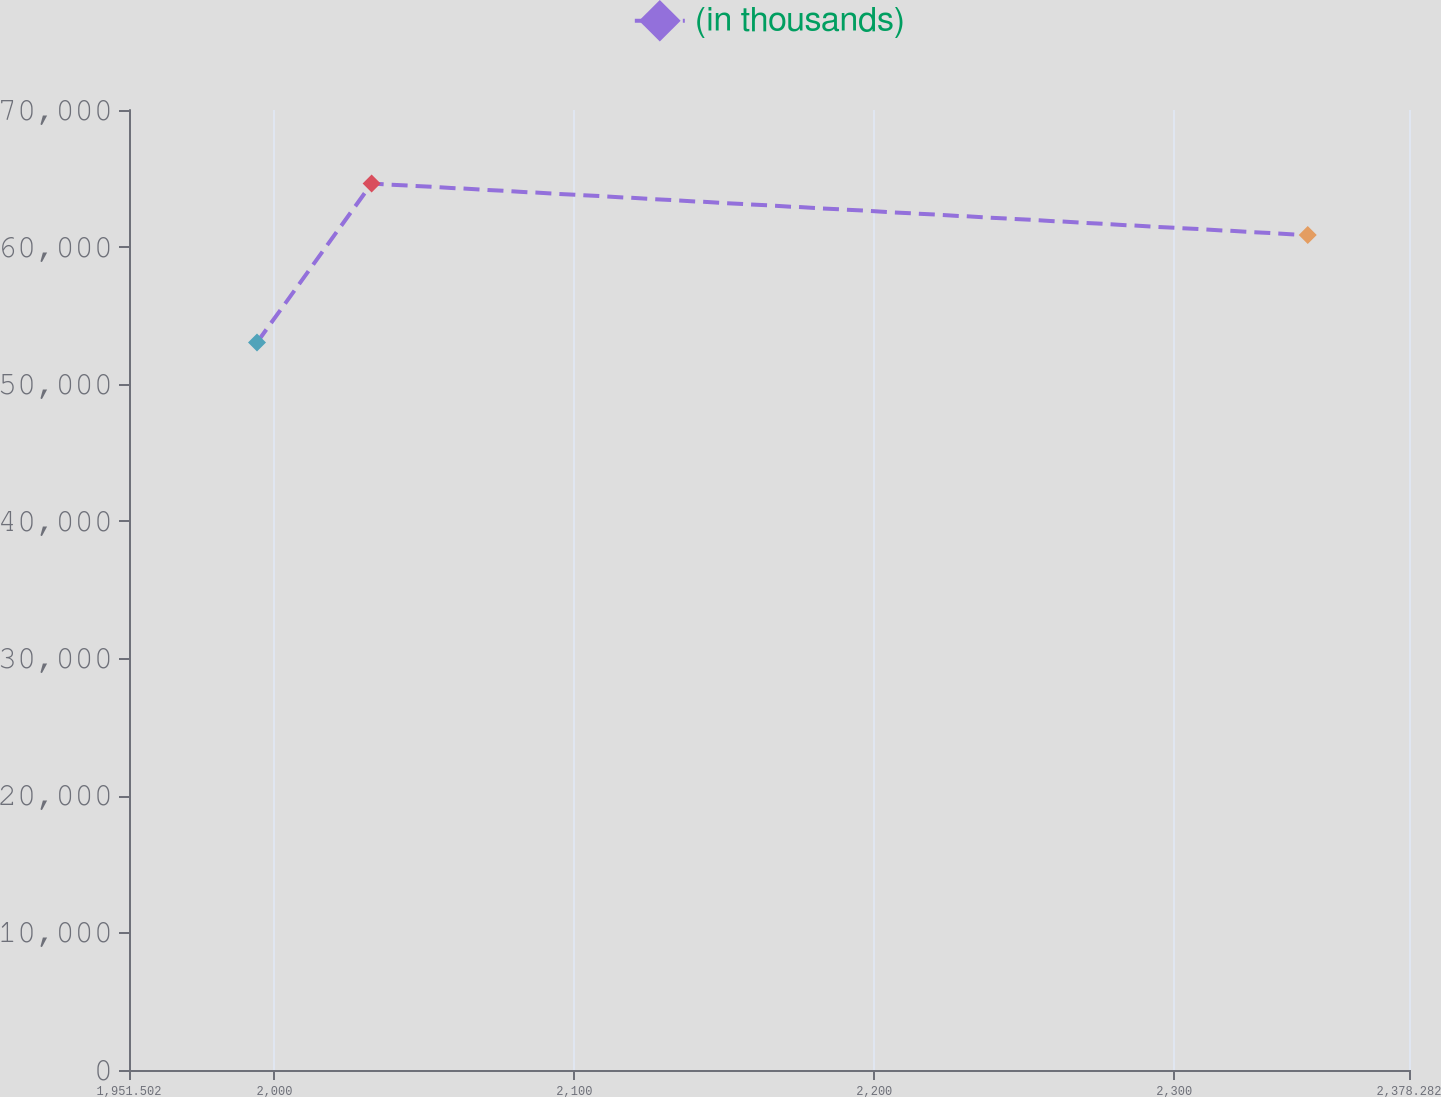Convert chart. <chart><loc_0><loc_0><loc_500><loc_500><line_chart><ecel><fcel>(in thousands)<nl><fcel>1994.18<fcel>53046.2<nl><fcel>2032.4<fcel>64636.3<nl><fcel>2344.52<fcel>60876.3<nl><fcel>2382.74<fcel>55752.6<nl><fcel>2420.96<fcel>62035.3<nl></chart> 